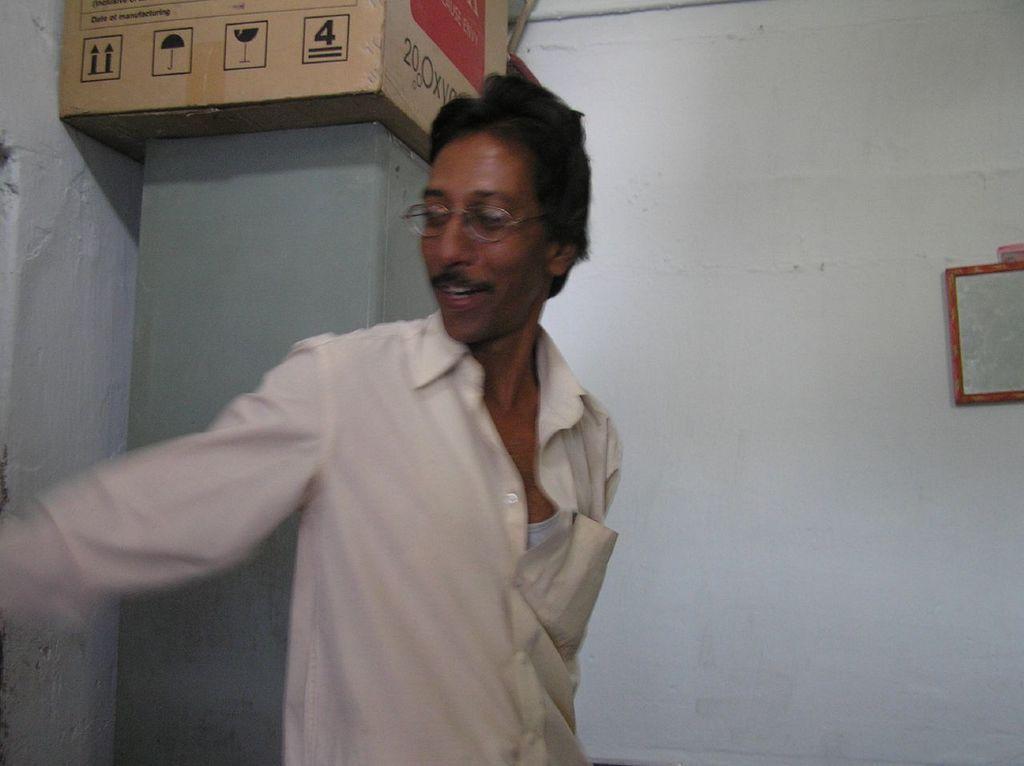Could you give a brief overview of what you see in this image? In this image I can see a person wearing white colored shirt and spectacles. In the background I can see a cupboard, a cardboard box on the cupboard, the white colored wall and a board attached to the wall. 